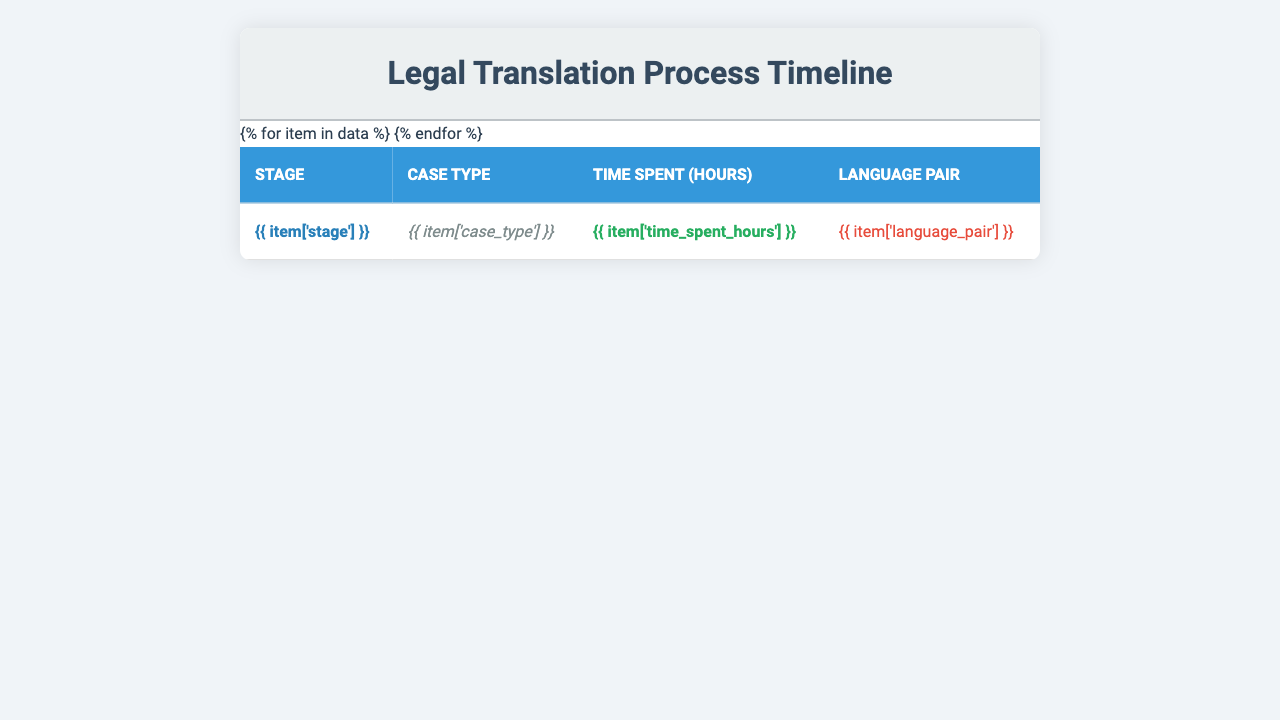What is the stage that took the longest time in the translation process? By reviewing the "Time Spent (hours)" column in the table, the stage with the maximum time spent is "Initial translation," which took 8.7 hours.
Answer: Initial translation What case type required the most hours for terminology research? Looking at the "Terminology research" stage, the case type is "International human rights," which took 5.2 hours.
Answer: International human rights How much time was spent on proofreading in total? The "Proofreading" stage shows a time spent of 4.3 hours. This is a single entry without the need for summation.
Answer: 4.3 hours Is the time spent on formatting less than 2 hours? The "Formatting" stage indicates 1.2 hours, which is indeed less than 2 hours.
Answer: Yes What is the average time spent across all stages? Adding up all the time spent: (3.5 + 5.2 + 8.7 + 2.1 + 4.3 + 1.8 + 2.5 + 1.2 + 3.6 + 6.4) = 39.9 hours. There are 10 stages, so the average is 39.9 / 10 = 3.99 hours.
Answer: 3.99 hours Which case type related to EU law involved the least time in client review? The "Client review" stage for "EU directives" took 1.8 hours, which is the only entry for client review related to EU law, hence it is the least.
Answer: EU directives How many stages took more than 5 hours to complete? From the table, only the "Initial translation" (8.7 hours) and "Glossary creation" (6.4 hours) stages exceed 5 hours, totaling 2 stages.
Answer: 2 stages Which stage has the highest time spent in the Bulgarian-German language pair? The "Quality assurance" stage for the case type "International criminal law" required 3.6 hours, which is the only entry for the Bulgarian-German pair in the data.
Answer: Quality assurance What is the total time spent on all stages related to international law? The relevant stages for international law are "Terminology research" (5.2 hours), "Initial translation" (8.7 hours), "Legal consultation" (2.1 hours), "Proofreading" (4.3 hours), "Quality assurance" (3.6 hours), and "Glossary creation" (6.4 hours). Adding these gives a total of 30.3 hours.
Answer: 30.3 hours Is there any stage where the time spent was exactly 2.5 hours? The "Final revisions" stage shows a time spent of exactly 2.5 hours, confirming that there is a stage meeting this criterion.
Answer: Yes 